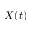<formula> <loc_0><loc_0><loc_500><loc_500>X ( t )</formula> 